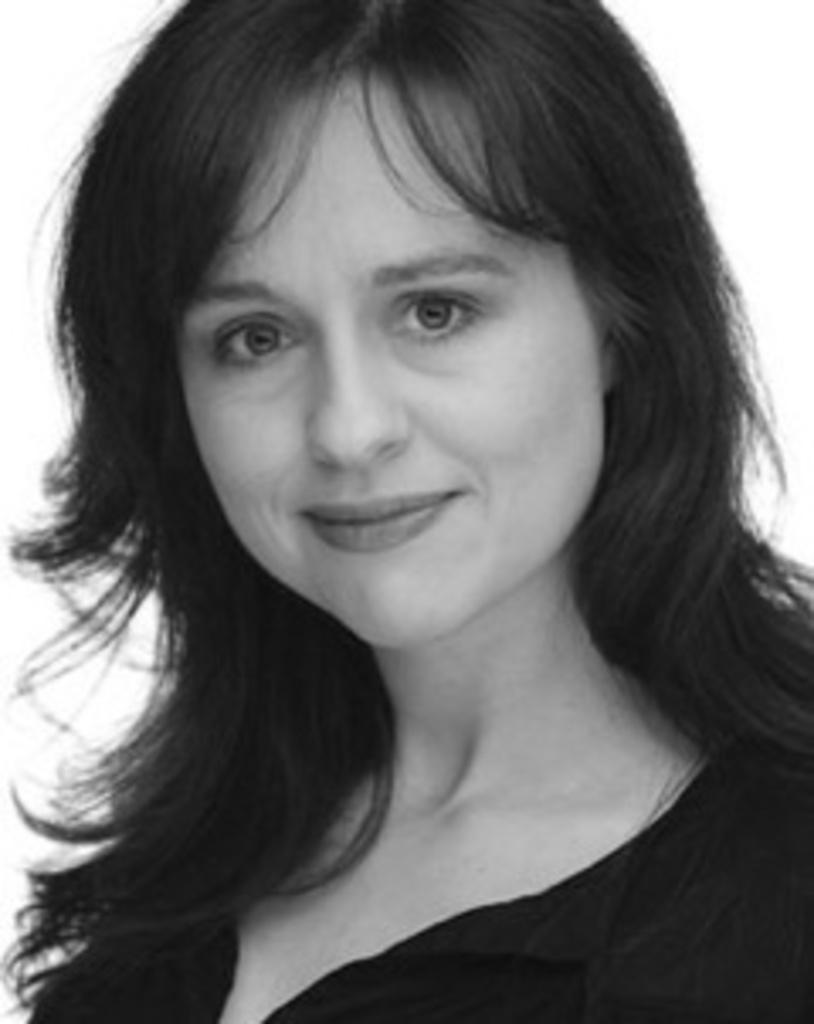What is the focus of the image? The image is zoomed in on a woman. Can you describe the woman in the image? The woman is in the center of the image, wearing a black dress, and smiling. What is the color of the background in the image? The background of the image is white in color. Are there any fairies visible in the wilderness behind the woman in the image? There are no fairies or wilderness present in the image; it features a woman in the center of a white background. 